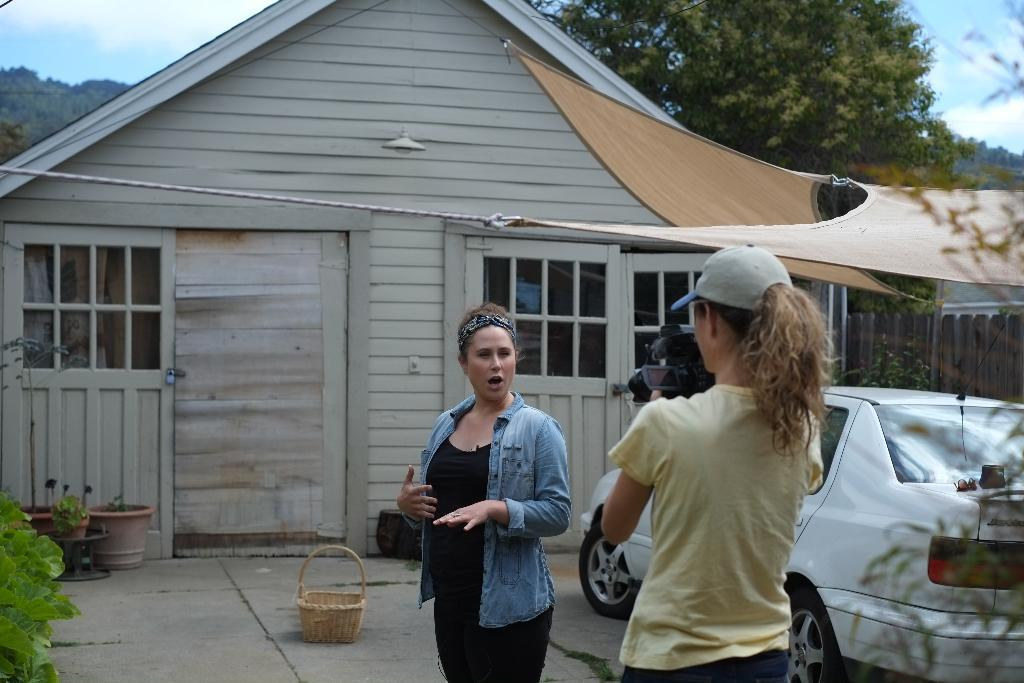How many people are in the image? There are two ladies in the image. What objects related to plants can be seen in the image? There are plant pots in the image. What mode of transportation is present in the image? There is a car in the image. What is on the floor in the image? There is a basket on the floor in the image. What type of house is featured in the image? The image features a wooden house. What type of vegetation is visible behind the house in the image? There are trees visible behind the house in the image. What color of paint is being used by the porter in the image? There is no porter or paint present in the image. How many baskets are visible in the image? There is only one basket visible in the image. 